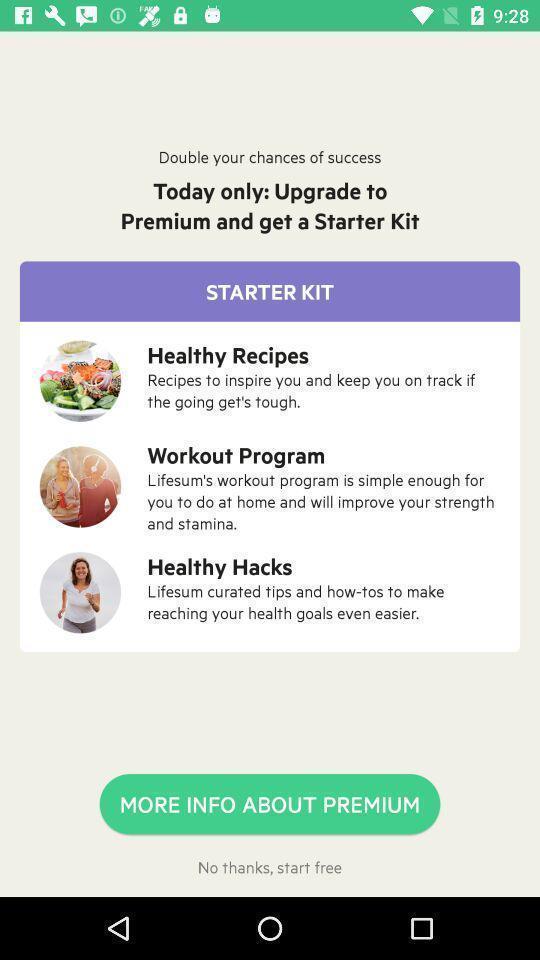Provide a detailed account of this screenshot. Subscription for starter kit with list of health program. 